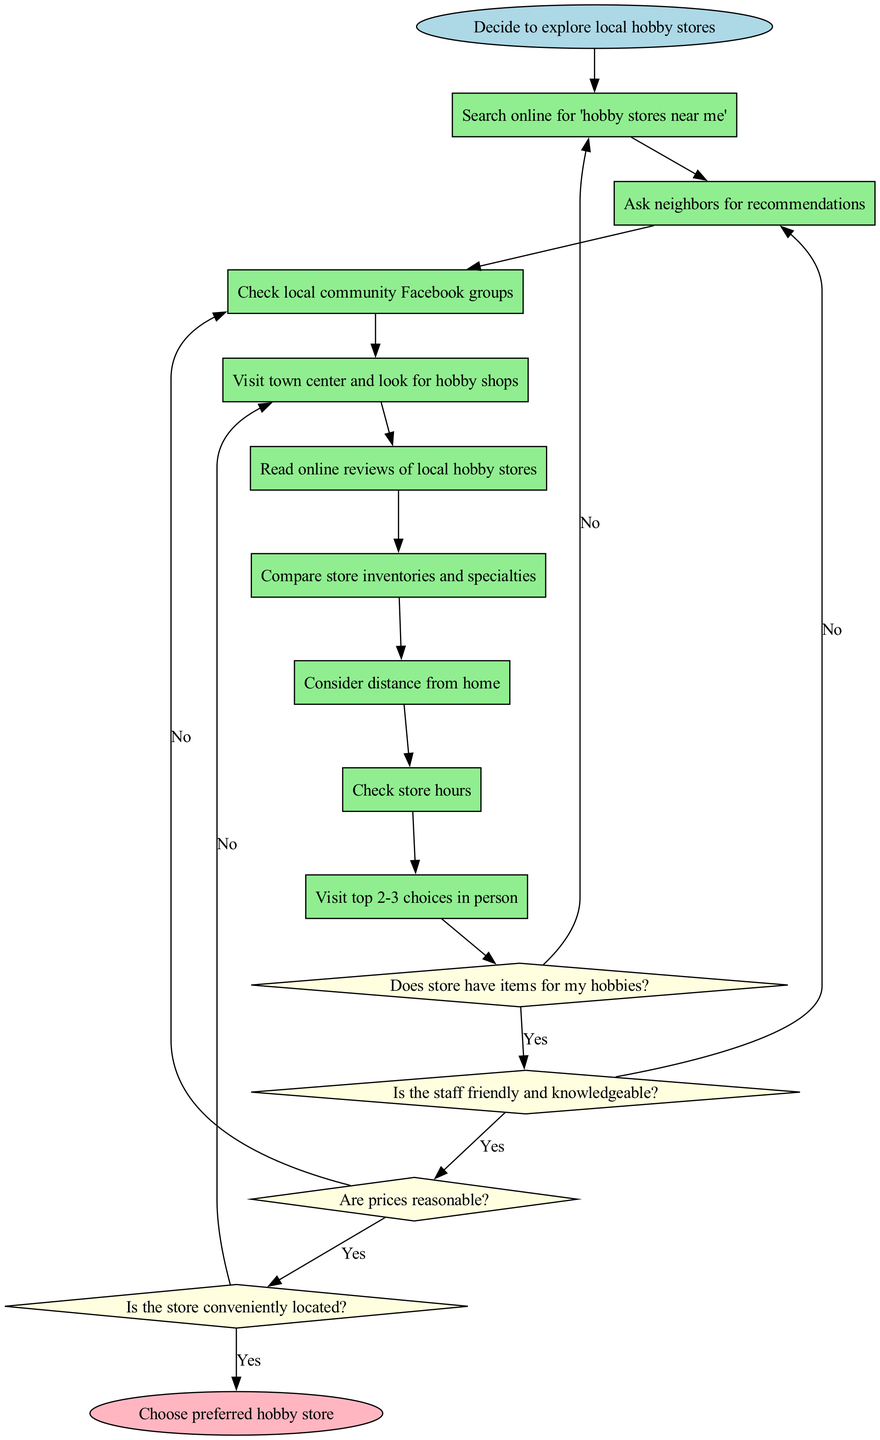What is the starting point of the process? The diagram begins with the node labeled "Decide to explore local hobby stores," indicating the initiation of the process.
Answer: Decide to explore local hobby stores How many actions are listed in the diagram? Counting the action nodes, there are a total of 9 actions specified in the diagram.
Answer: 9 What is the last decision point in the flowchart? The final decision node in the diagram is "Is the store conveniently located?," which evaluates the suitability of a store regarding its location.
Answer: Is the store conveniently located? What is the outcome if a store has items for my hobbies? If the answer to the question about whether the store has items for the hobby is "Yes," it proceeds to the next question, which is "Is the staff friendly and knowledgeable?"
Answer: Is the staff friendly and knowledgeable? If the decision about the store’s location is "No," what happens next? If the decision regarding whether the store is conveniently located is "No," the process loops back to the previous action node, which is "Compare store inventories and specialties."
Answer: Compare store inventories and specialties How many decision nodes are there in total? The diagram contains 4 decision nodes that evaluate the suitability of the stores based on various criteria.
Answer: 4 What color represents the action nodes in the flowchart? The action nodes are represented in light green, distinguishing them from other types of nodes in the diagram.
Answer: Light green What happens after all decisions are assessed positively? After all decision nodes are answered positively, the flowchart leads to the final node, which is "Choose preferred hobby store."
Answer: Choose preferred hobby store What is the first action taken after deciding to explore hobby stores? The first action listed after the starting point is "Search online for 'hobby stores near me'," marking the initial step in the process.
Answer: Search online for 'hobby stores near me' 